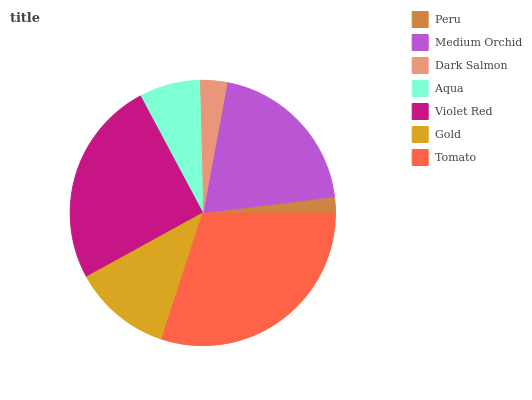Is Peru the minimum?
Answer yes or no. Yes. Is Tomato the maximum?
Answer yes or no. Yes. Is Medium Orchid the minimum?
Answer yes or no. No. Is Medium Orchid the maximum?
Answer yes or no. No. Is Medium Orchid greater than Peru?
Answer yes or no. Yes. Is Peru less than Medium Orchid?
Answer yes or no. Yes. Is Peru greater than Medium Orchid?
Answer yes or no. No. Is Medium Orchid less than Peru?
Answer yes or no. No. Is Gold the high median?
Answer yes or no. Yes. Is Gold the low median?
Answer yes or no. Yes. Is Peru the high median?
Answer yes or no. No. Is Tomato the low median?
Answer yes or no. No. 